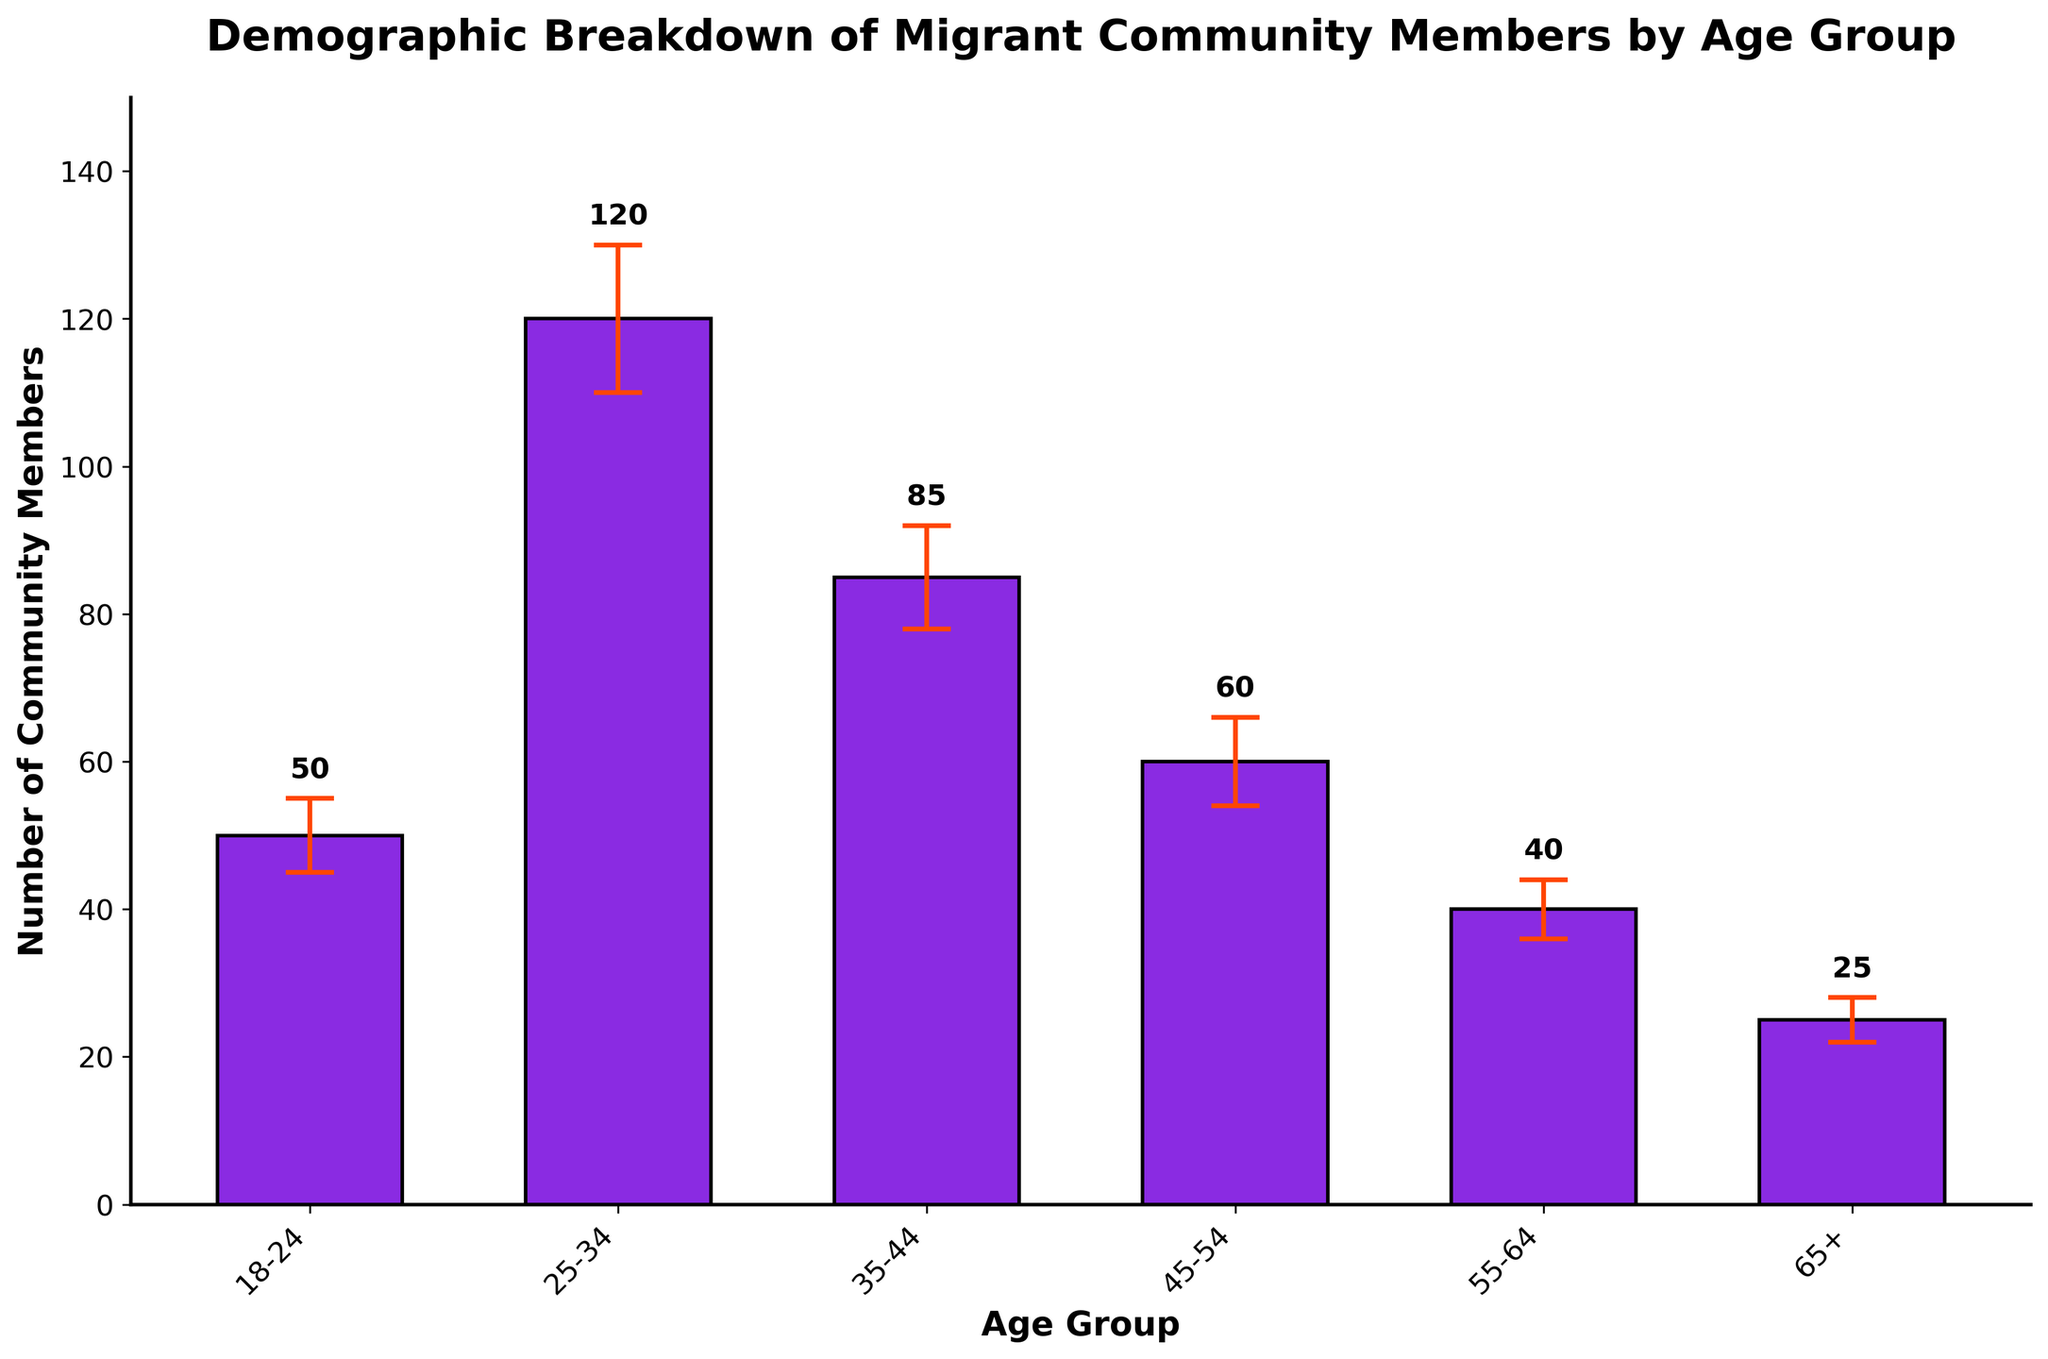What is the title of the bar chart? The title of the chart is displayed at the top in a larger and bold font. It provides an overview of what the chart is depicting.
Answer: Demographic Breakdown of Migrant Community Members by Age Group Which age group has the highest mean number of community members? By looking at the height of the bars, which represents the mean number of community members, the tallest bar indicates the age group with the highest mean.
Answer: 25-34 What is the mean number of community members for the 65+ age group? The bar corresponding to the 65+ age group shows the mean number of community members at its peak value, which is labeled above the bar.
Answer: 25 What is the standard deviation for the 18-24 age group? The error bars above each bar represent the standard deviation. For the 18-24 age group, the error bar length corresponds to the standard deviation.
Answer: 5 How many age groups are present in the chart? Counting the number of distinct bars, each representing a different age group, reveals the total number of age groups.
Answer: 6 Which age group has the smallest variation in community members? The variation is depicted by the length of the error bars. The age group with the shortest error bar has the smallest variation.
Answer: 65+ What is the total mean number of community members for all age groups combined? Summing up the mean number of community members for all age groups provides the total. 50 + 120 + 85 + 60 + 40 + 25
Answer: 380 Is the standard deviation for the 25-34 age group greater than for the 45-54 age group? Comparing the lengths of the error bars for these two age groups shows whether one is greater than the other.
Answer: Yes What is the range of mean numbers for community members among the age groups? The range is calculated by subtracting the smallest mean number from the largest mean number. The minimum is 25 (65+ age group) and the maximum is 120 (25-34 age group). 120 - 25
Answer: 95 